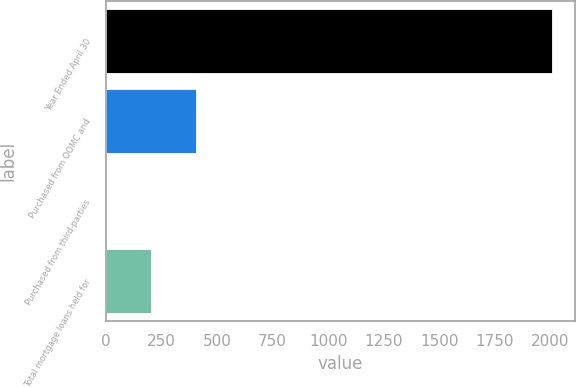<chart> <loc_0><loc_0><loc_500><loc_500><bar_chart><fcel>Year Ended April 30<fcel>Purchased from OOMC and<fcel>Purchased from third-parties<fcel>Total mortgage loans held for<nl><fcel>2008<fcel>403.12<fcel>1.9<fcel>202.51<nl></chart> 